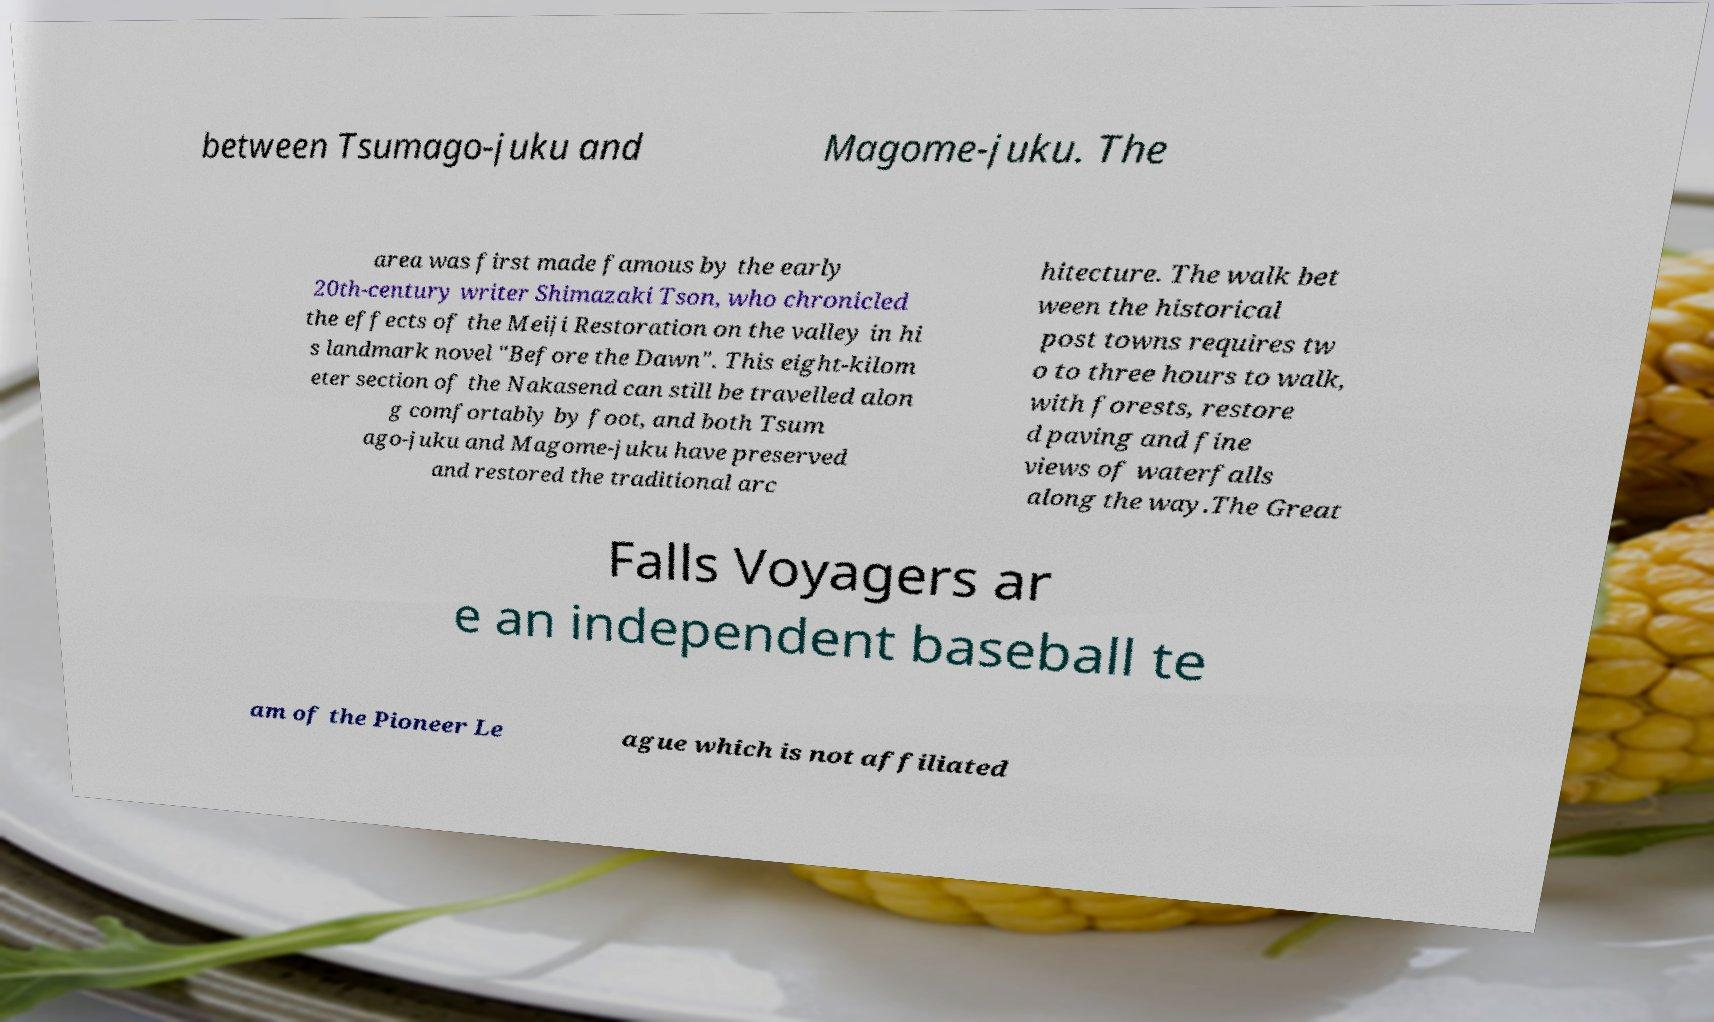Please read and relay the text visible in this image. What does it say? between Tsumago-juku and Magome-juku. The area was first made famous by the early 20th-century writer Shimazaki Tson, who chronicled the effects of the Meiji Restoration on the valley in hi s landmark novel "Before the Dawn". This eight-kilom eter section of the Nakasend can still be travelled alon g comfortably by foot, and both Tsum ago-juku and Magome-juku have preserved and restored the traditional arc hitecture. The walk bet ween the historical post towns requires tw o to three hours to walk, with forests, restore d paving and fine views of waterfalls along the way.The Great Falls Voyagers ar e an independent baseball te am of the Pioneer Le ague which is not affiliated 